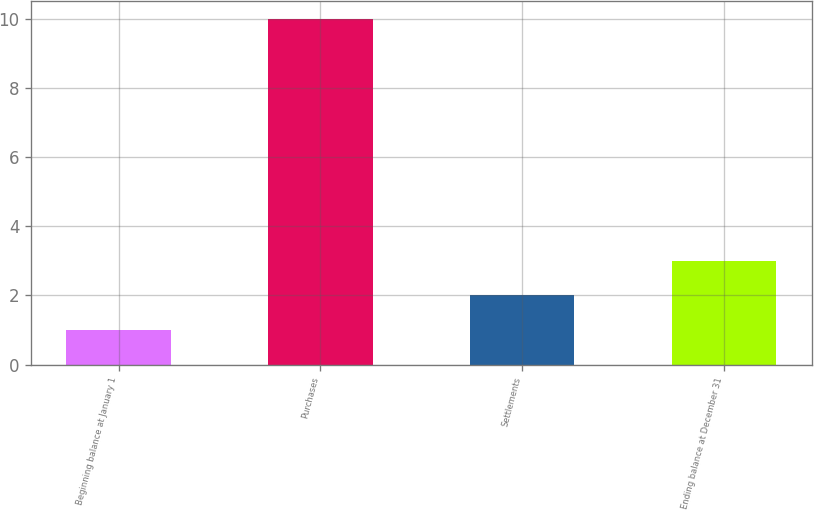Convert chart. <chart><loc_0><loc_0><loc_500><loc_500><bar_chart><fcel>Beginning balance at January 1<fcel>Purchases<fcel>Settlements<fcel>Ending balance at December 31<nl><fcel>1<fcel>10<fcel>2<fcel>3<nl></chart> 